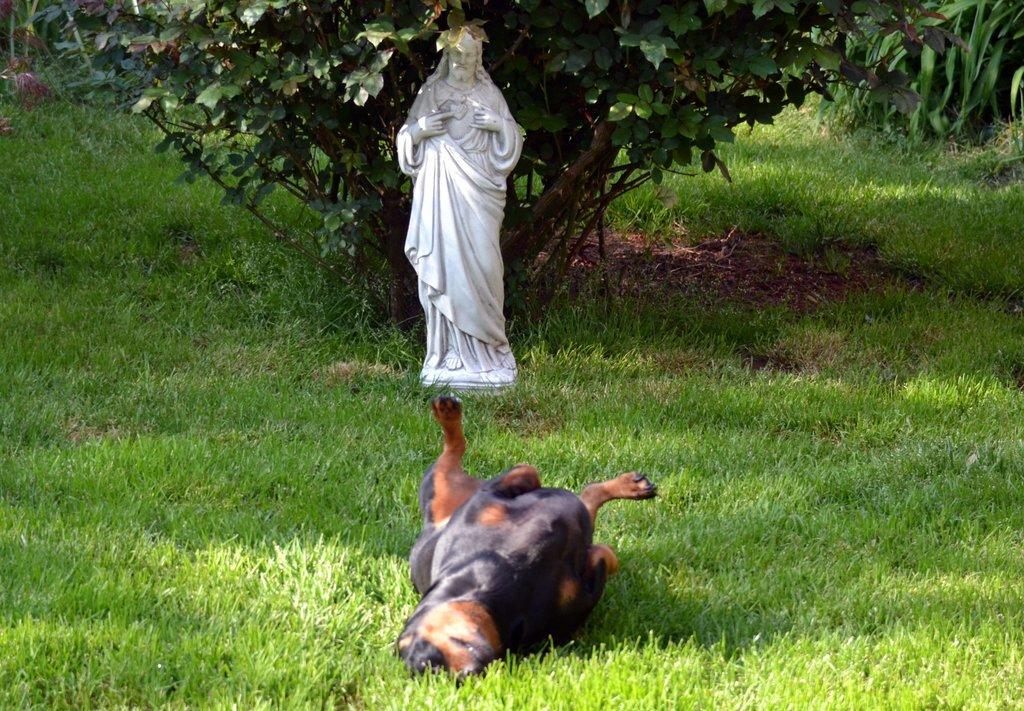What is located on the ground in the image? There is a statue on the ground. What is the dog doing in the image? The dog is lying on the grass field. What type of vegetation can be seen in the image? There are plants and a tree visible in the image. How many ants can be seen carrying a picture in the image? There are no ants or pictures present in the image. What degree of difficulty is the tree in the image rated for climbing? The image does not provide information about the difficulty of climbing the tree, nor is there any mention of a degree of difficulty. 